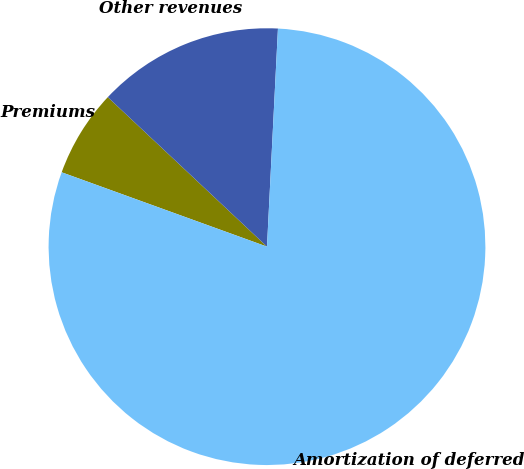Convert chart. <chart><loc_0><loc_0><loc_500><loc_500><pie_chart><fcel>Premiums<fcel>Other revenues<fcel>Amortization of deferred<nl><fcel>6.47%<fcel>13.8%<fcel>79.73%<nl></chart> 